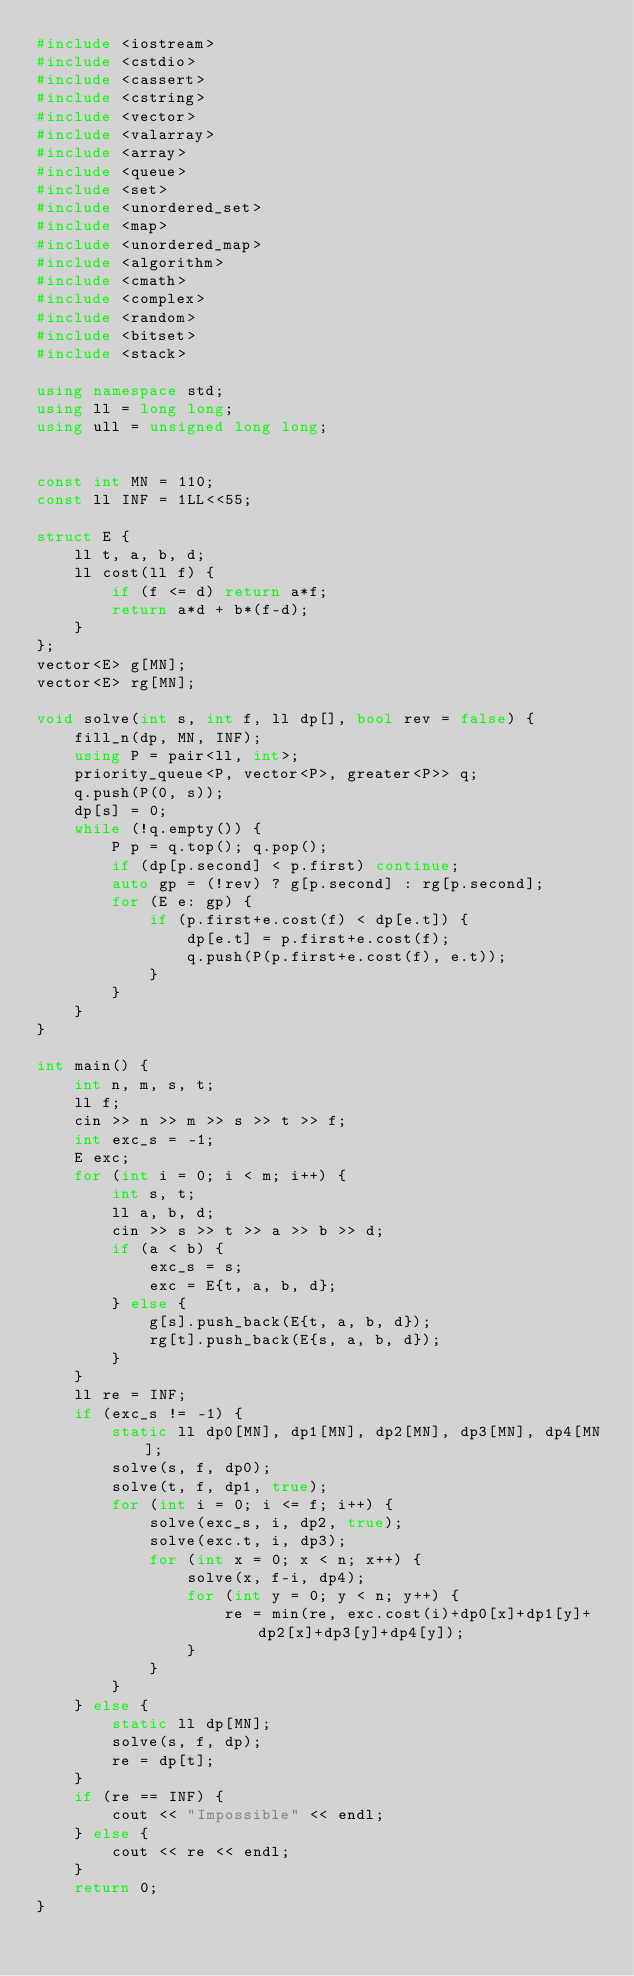Convert code to text. <code><loc_0><loc_0><loc_500><loc_500><_C++_>#include <iostream>
#include <cstdio>
#include <cassert>
#include <cstring>
#include <vector>
#include <valarray>
#include <array>
#include <queue>
#include <set>
#include <unordered_set>
#include <map>
#include <unordered_map>
#include <algorithm>
#include <cmath>
#include <complex>
#include <random>
#include <bitset>
#include <stack>

using namespace std;
using ll = long long;
using ull = unsigned long long;


const int MN = 110;
const ll INF = 1LL<<55;

struct E {
    ll t, a, b, d;
    ll cost(ll f) {
        if (f <= d) return a*f;
        return a*d + b*(f-d);
    }
};
vector<E> g[MN];
vector<E> rg[MN];

void solve(int s, int f, ll dp[], bool rev = false) {
    fill_n(dp, MN, INF);
    using P = pair<ll, int>;
    priority_queue<P, vector<P>, greater<P>> q;
    q.push(P(0, s));
    dp[s] = 0;
    while (!q.empty()) {
        P p = q.top(); q.pop();
        if (dp[p.second] < p.first) continue;
        auto gp = (!rev) ? g[p.second] : rg[p.second];
        for (E e: gp) {
            if (p.first+e.cost(f) < dp[e.t]) {
                dp[e.t] = p.first+e.cost(f);
                q.push(P(p.first+e.cost(f), e.t));
            }
        }
    }
}

int main() {
    int n, m, s, t;
    ll f;
    cin >> n >> m >> s >> t >> f;
    int exc_s = -1;
    E exc;
    for (int i = 0; i < m; i++) {
        int s, t;
        ll a, b, d;
        cin >> s >> t >> a >> b >> d;
        if (a < b) {
            exc_s = s;
            exc = E{t, a, b, d};
        } else {
            g[s].push_back(E{t, a, b, d});
            rg[t].push_back(E{s, a, b, d});
        }
    }
    ll re = INF;
    if (exc_s != -1) {
        static ll dp0[MN], dp1[MN], dp2[MN], dp3[MN], dp4[MN];
        solve(s, f, dp0);
        solve(t, f, dp1, true);
        for (int i = 0; i <= f; i++) {
            solve(exc_s, i, dp2, true);
            solve(exc.t, i, dp3);
            for (int x = 0; x < n; x++) {
                solve(x, f-i, dp4);
                for (int y = 0; y < n; y++) {
                    re = min(re, exc.cost(i)+dp0[x]+dp1[y]+dp2[x]+dp3[y]+dp4[y]);
                }
            }
        }
    } else {
        static ll dp[MN];
        solve(s, f, dp);
        re = dp[t];
    }
    if (re == INF) {
        cout << "Impossible" << endl;
    } else {
        cout << re << endl;
    }
    return 0;
}</code> 